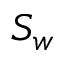<formula> <loc_0><loc_0><loc_500><loc_500>S _ { w }</formula> 